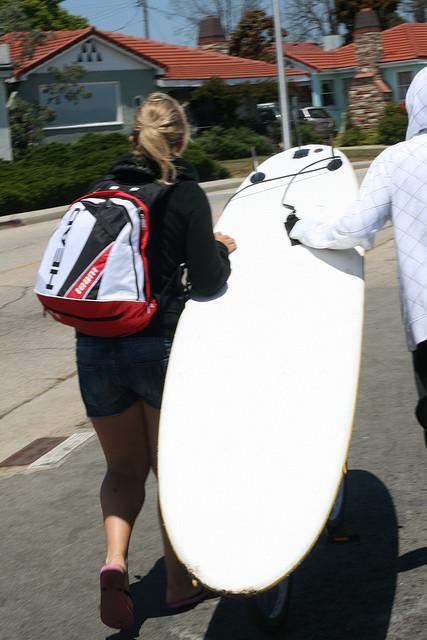What is the brand of the girl's backpack?
Quick response, please. Head. What is the woman holding in her hands?
Give a very brief answer. Surfboard. What is on the person's head?
Answer briefly. Hood. Is the woman young?
Keep it brief. Yes. 